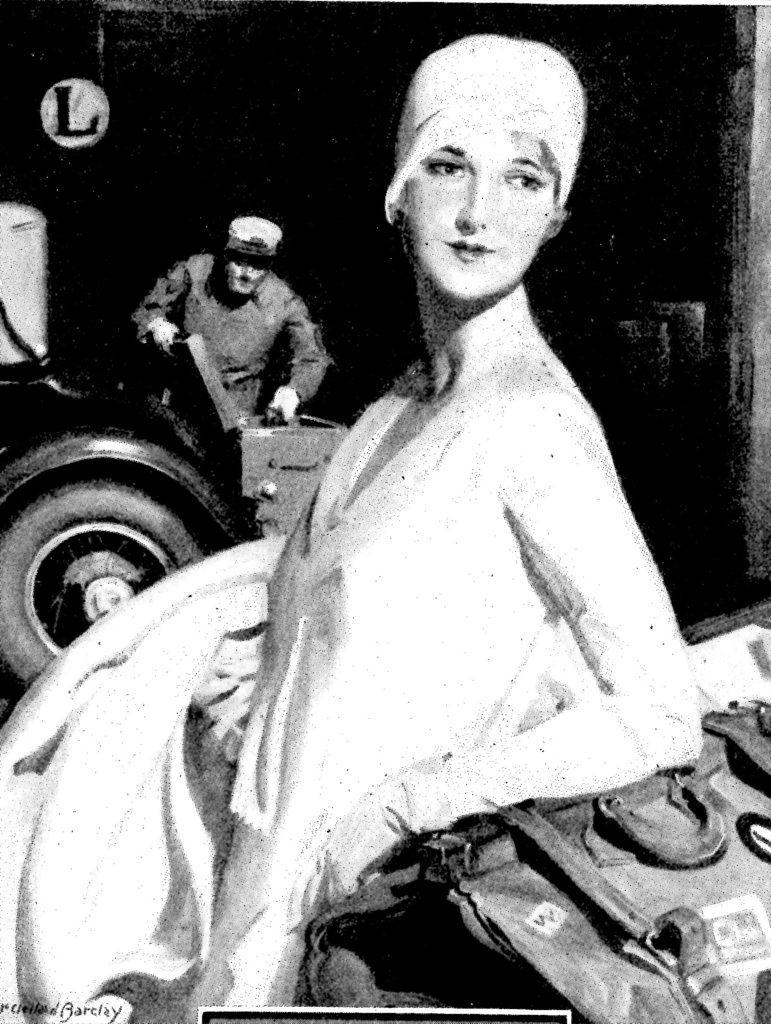Describe this image in one or two sentences. It is a black and white picture. In the image in the center we can see two persons were standing. And we can see a vehicle and backpack. On the left bottom there is a watermark. In the background we can see a wall,sign board and few other objects. 